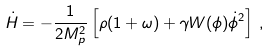Convert formula to latex. <formula><loc_0><loc_0><loc_500><loc_500>\dot { H } = - \frac { 1 } { 2 M _ { p } ^ { 2 } } \left [ \rho ( 1 + \omega ) + \gamma W ( \phi ) \dot { \phi } ^ { 2 } \right ] \, ,</formula> 